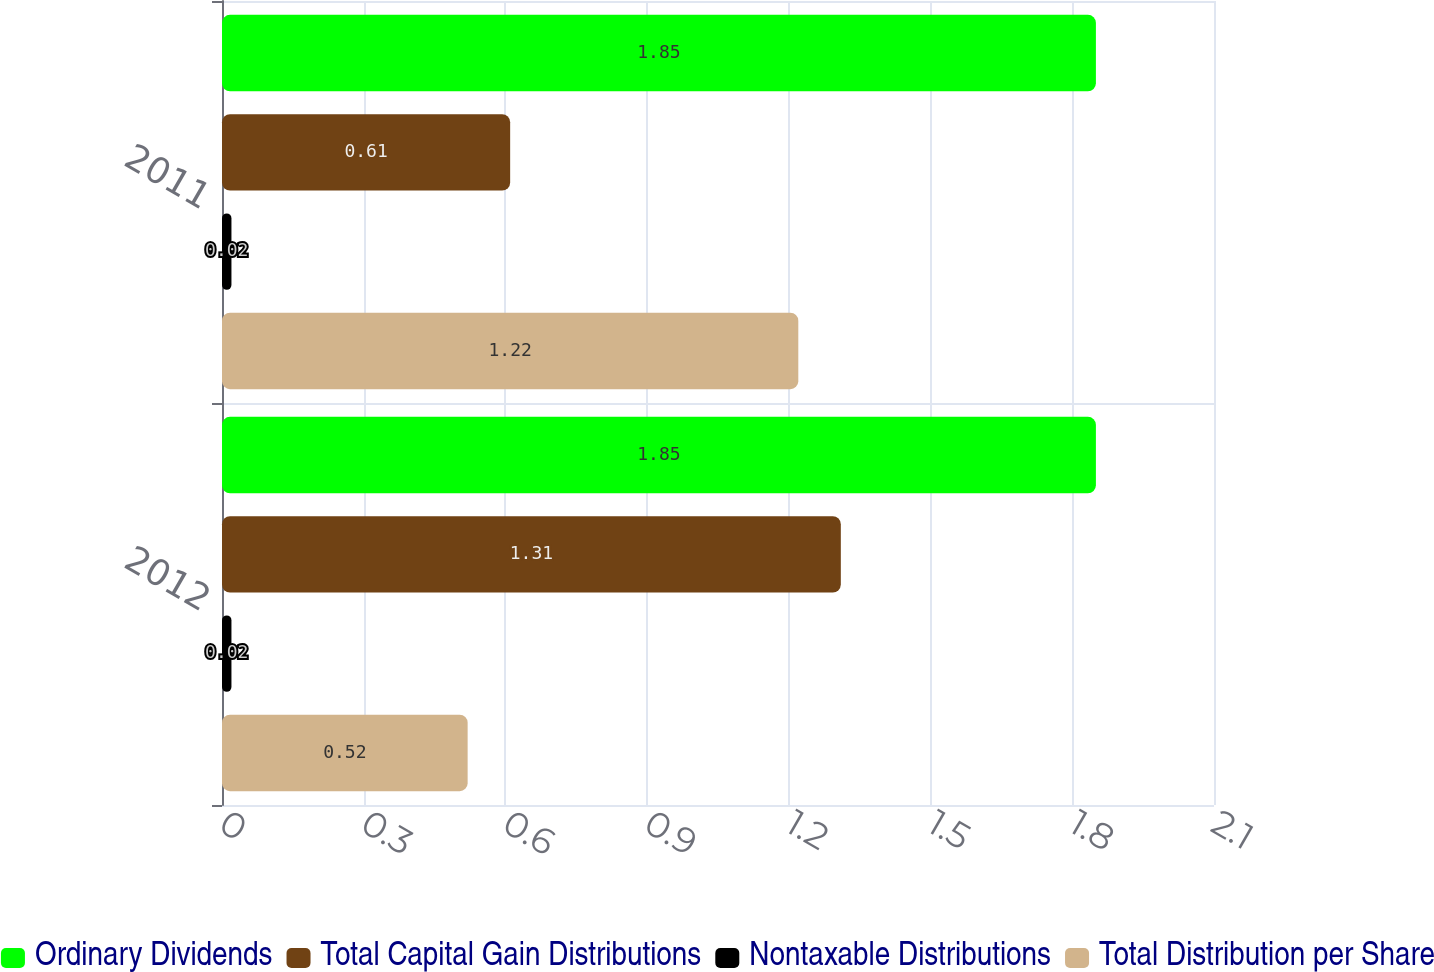Convert chart. <chart><loc_0><loc_0><loc_500><loc_500><stacked_bar_chart><ecel><fcel>2012<fcel>2011<nl><fcel>Ordinary Dividends<fcel>1.85<fcel>1.85<nl><fcel>Total Capital Gain Distributions<fcel>1.31<fcel>0.61<nl><fcel>Nontaxable Distributions<fcel>0.02<fcel>0.02<nl><fcel>Total Distribution per Share<fcel>0.52<fcel>1.22<nl></chart> 